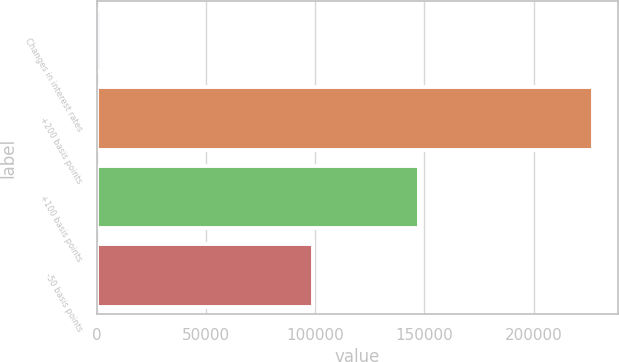Convert chart. <chart><loc_0><loc_0><loc_500><loc_500><bar_chart><fcel>Changes in interest rates<fcel>+200 basis points<fcel>+100 basis points<fcel>-50 basis points<nl><fcel>2016<fcel>227283<fcel>147400<fcel>98945<nl></chart> 